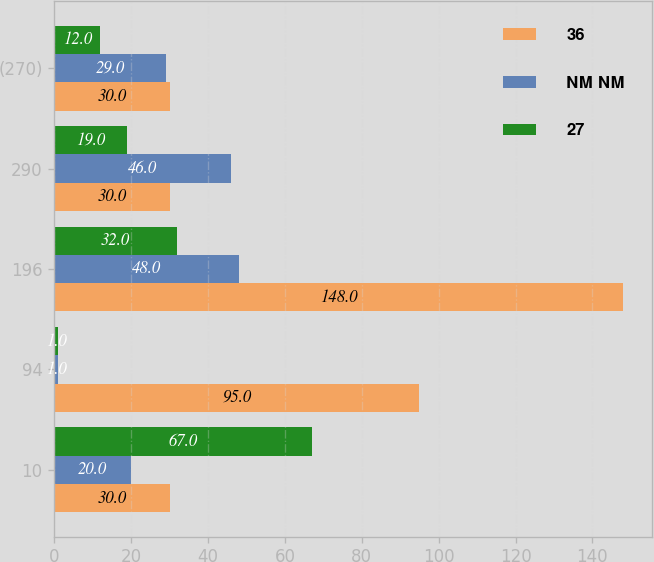<chart> <loc_0><loc_0><loc_500><loc_500><stacked_bar_chart><ecel><fcel>10<fcel>94<fcel>196<fcel>290<fcel>(270)<nl><fcel>36<fcel>30<fcel>95<fcel>148<fcel>30<fcel>30<nl><fcel>NM NM<fcel>20<fcel>1<fcel>48<fcel>46<fcel>29<nl><fcel>27<fcel>67<fcel>1<fcel>32<fcel>19<fcel>12<nl></chart> 